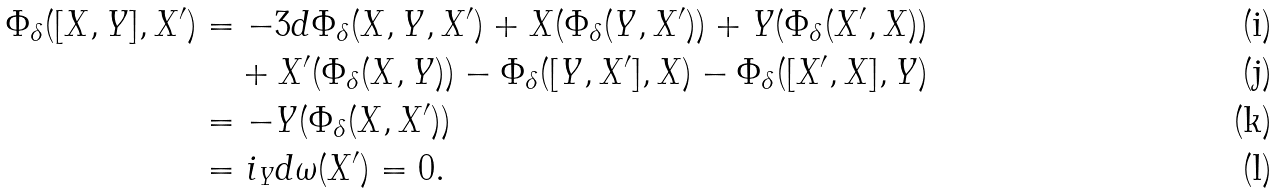<formula> <loc_0><loc_0><loc_500><loc_500>\Phi _ { \delta } ( [ X , Y ] , X ^ { \prime } ) & = - 3 d \Phi _ { \delta } ( X , Y , X ^ { \prime } ) + X ( \Phi _ { \delta } ( Y , X ^ { \prime } ) ) + Y ( \Phi _ { \delta } ( X ^ { \prime } , X ) ) \\ & \quad + X ^ { \prime } ( \Phi _ { \delta } ( X , Y ) ) - \Phi _ { \delta } ( [ Y , X ^ { \prime } ] , X ) - \Phi _ { \delta } ( [ X ^ { \prime } , X ] , Y ) \\ & = - Y ( \Phi _ { \delta } ( X , X ^ { \prime } ) ) \\ & = i _ { Y } d \omega ( X ^ { \prime } ) = 0 .</formula> 